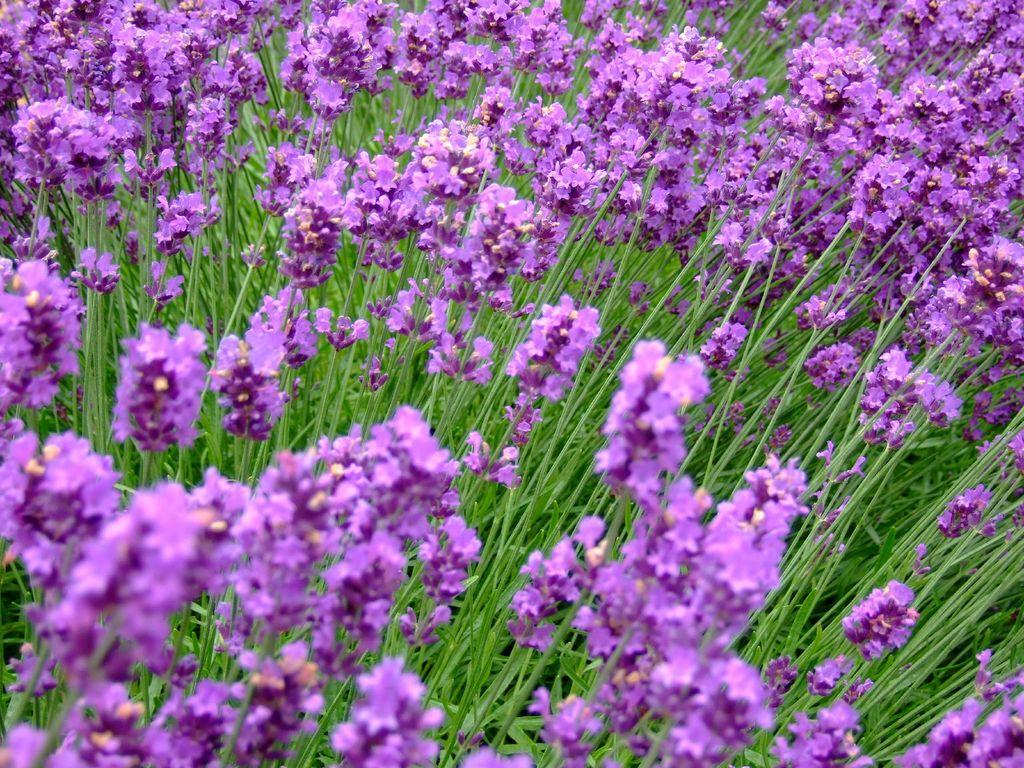What type of garden is shown in the image? There is a flower garden in the image. What can be found in the flower garden? There are many plants in the image. What are the characteristics of the plants in the garden? The plants have flowers. What is the color of the flowers in the image? The flowers are in pink color. Can you tell me how many nuts are present in the flower garden? There are no nuts present in the flower garden; the image features a garden with plants and flowers. What type of leg is visible in the image? There is no leg visible in the image; it features a flower garden with plants and flowers. 